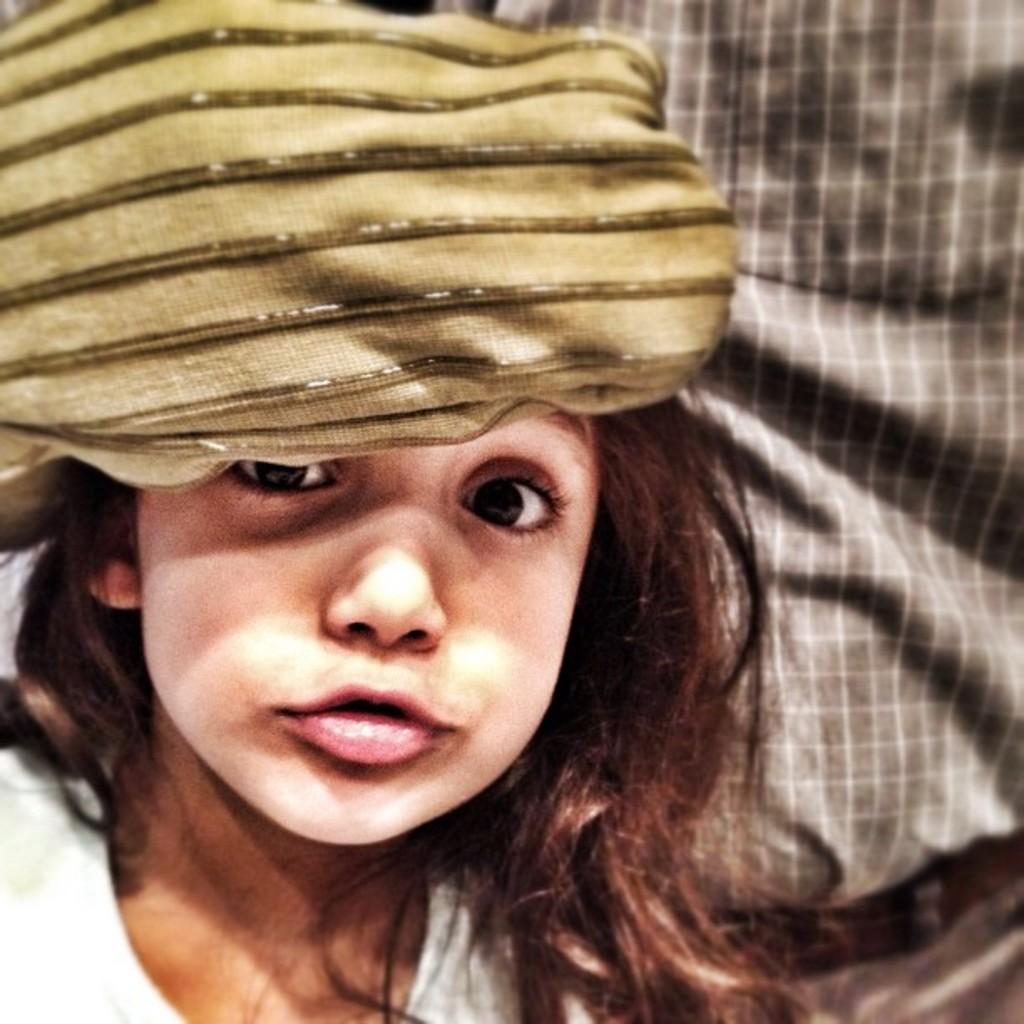Can you describe this image briefly? In front of the picture, we see a girl in white dress is looking at the camera. She is wearing a green color head scarf. In the background, we see a man in grey shirt is standing. 